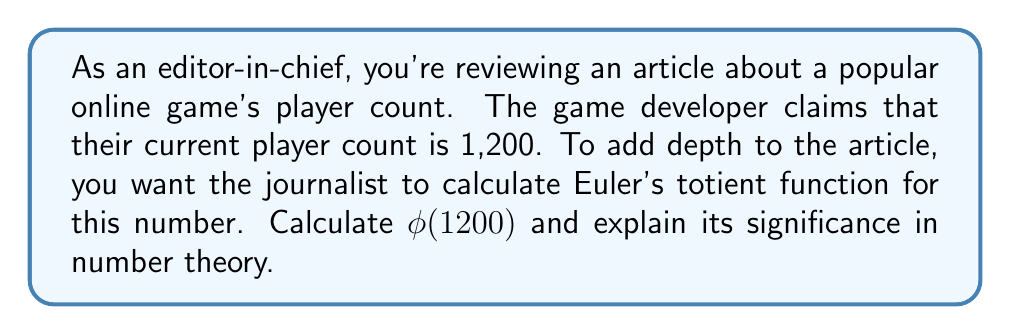Provide a solution to this math problem. To calculate Euler's totient function $\phi(1200)$, we'll follow these steps:

1) First, let's factor 1200 into its prime factors:
   $1200 = 2^4 \times 3 \times 5^2$

2) For a prime power $p^k$, the formula for Euler's totient function is:
   $\phi(p^k) = p^k - p^{k-1} = p^k(1 - \frac{1}{p})$

3) For a product of relatively prime numbers, Euler's totient function is multiplicative:
   $\phi(ab) = \phi(a) \times \phi(b)$ if $a$ and $b$ are coprime

4) Now, let's calculate for each prime factor:

   For $2^4$: $\phi(2^4) = 2^4 - 2^3 = 16 - 8 = 8$
   For $3$:   $\phi(3) = 3 - 1 = 2$
   For $5^2$: $\phi(5^2) = 5^2 - 5 = 25 - 5 = 20$

5) Multiply these results:
   $\phi(1200) = \phi(2^4) \times \phi(3) \times \phi(5^2) = 8 \times 2 \times 20 = 320$

The significance of Euler's totient function in number theory is that $\phi(n)$ counts the number of integers up to $n$ that are coprime to $n$. In this context, it means there are 320 numbers less than or equal to 1200 that share no common factors with 1200 other than 1.

This concept is crucial in various areas of number theory and cryptography, particularly in algorithms involving modular arithmetic and in the RSA encryption system.
Answer: $\phi(1200) = 320$ 